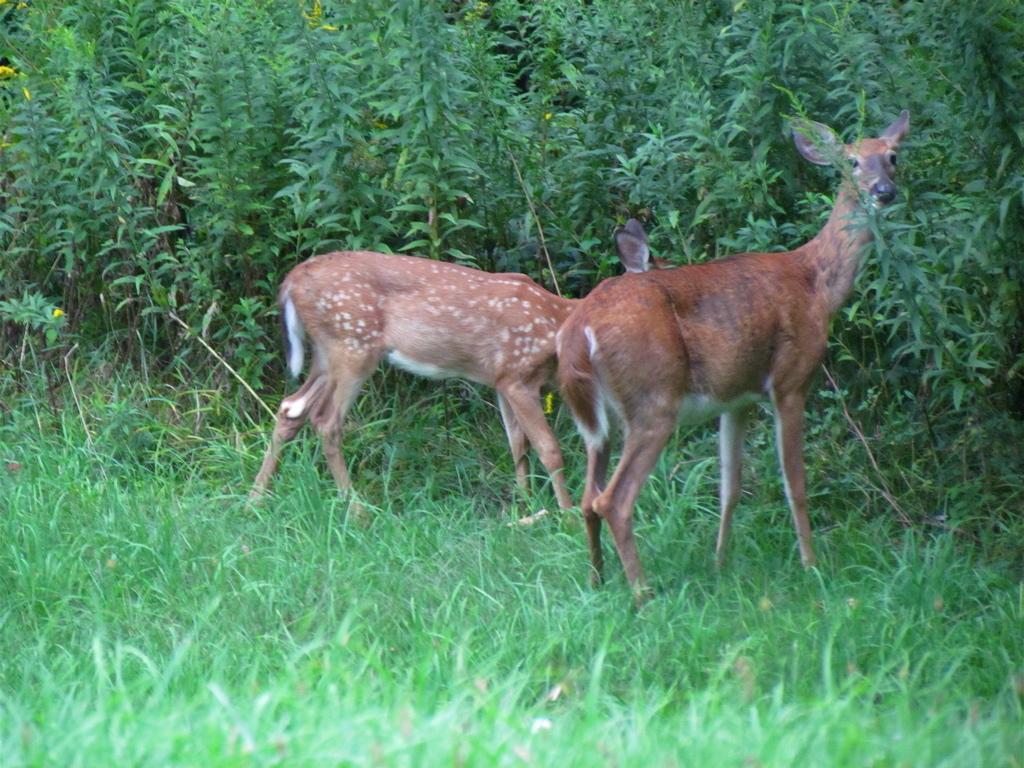Can you describe this image briefly? In this image we can see two deer are standing on the grass. In the background we can see plants. 